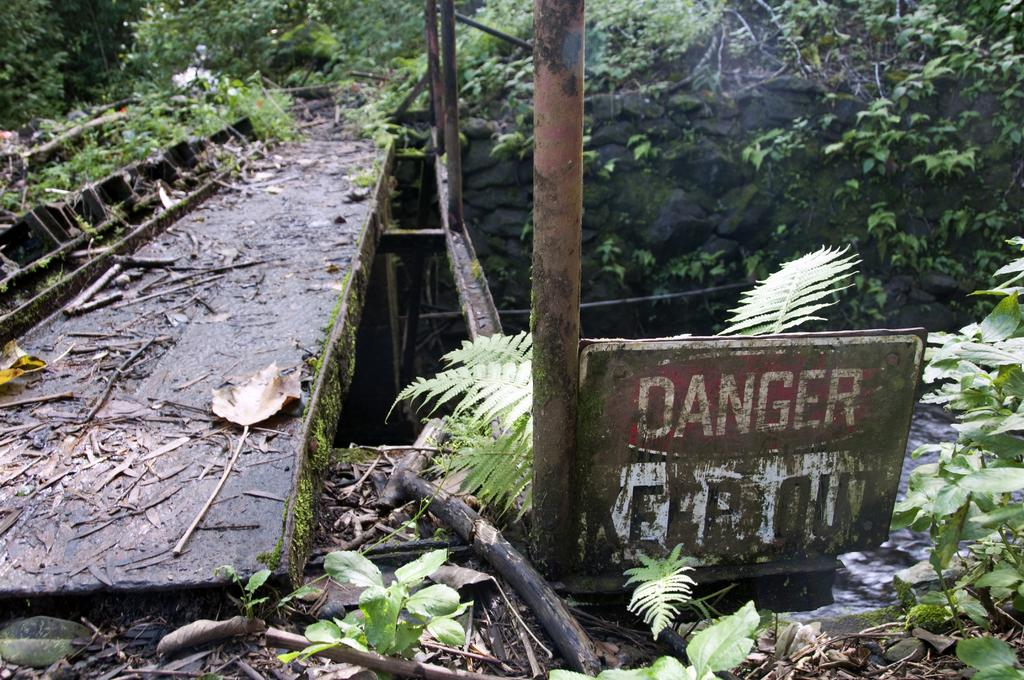What is the main object in the image? There is a signboard in the image. What else can be seen in the image besides the signboard? Sticks, dried leaves on a path, rods, and a wall are present in the image. What is visible in the background of the image? Trees are visible in the background of the image. What type of iron is being used to cook food in the image? There is no iron or cooking activity present in the image. Can you see your mom in the image? There is no person, including your mom, present in the image. 